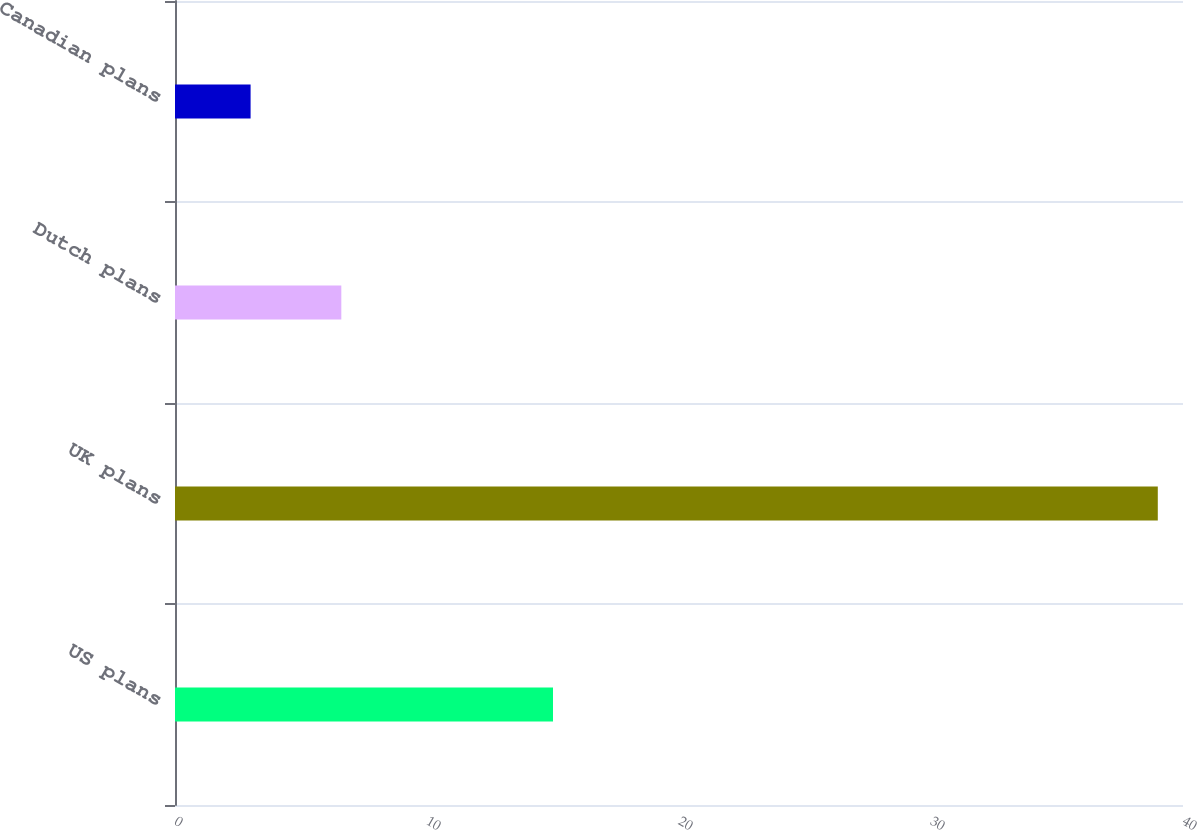<chart> <loc_0><loc_0><loc_500><loc_500><bar_chart><fcel>US plans<fcel>UK plans<fcel>Dutch plans<fcel>Canadian plans<nl><fcel>15<fcel>39<fcel>6.6<fcel>3<nl></chart> 